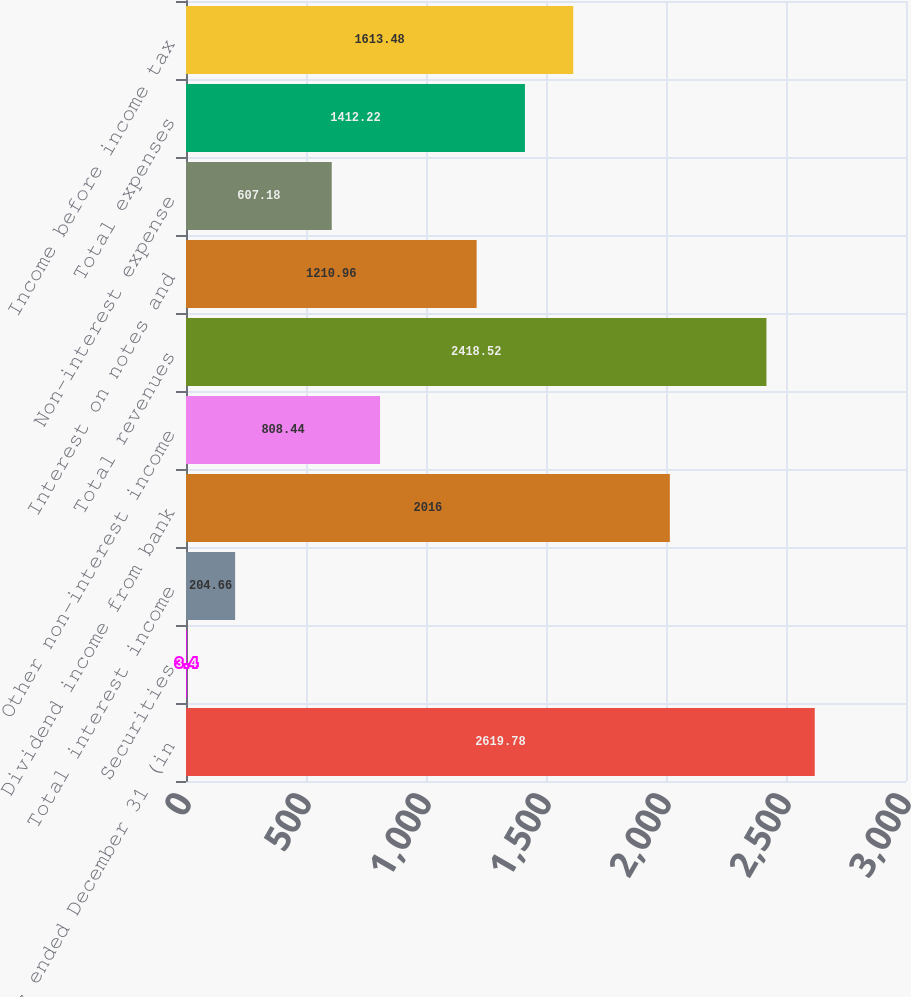Convert chart. <chart><loc_0><loc_0><loc_500><loc_500><bar_chart><fcel>Years ended December 31 (in<fcel>Securities<fcel>Total interest income<fcel>Dividend income from bank<fcel>Other non-interest income<fcel>Total revenues<fcel>Interest on notes and<fcel>Non-interest expense<fcel>Total expenses<fcel>Income before income tax<nl><fcel>2619.78<fcel>3.4<fcel>204.66<fcel>2016<fcel>808.44<fcel>2418.52<fcel>1210.96<fcel>607.18<fcel>1412.22<fcel>1613.48<nl></chart> 